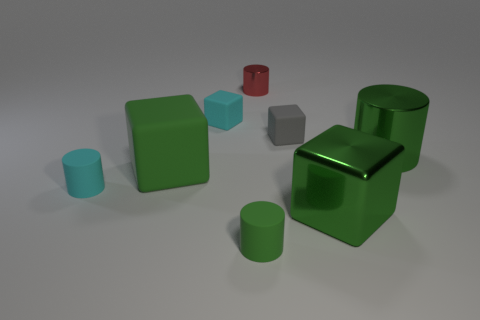Do the gray object and the tiny red thing have the same shape?
Keep it short and to the point. No. There is a gray block that is in front of the tiny matte cube that is left of the small thing that is right of the tiny metal object; what is its size?
Your response must be concise. Small. What number of other things are there of the same material as the small red object
Offer a very short reply. 2. There is a metallic object that is behind the small gray thing; what is its color?
Make the answer very short. Red. There is a green cylinder to the right of the tiny rubber thing that is in front of the block to the right of the small gray rubber object; what is its material?
Provide a succinct answer. Metal. Is there another red metallic thing of the same shape as the small red metallic thing?
Offer a very short reply. No. The red metallic object that is the same size as the gray block is what shape?
Ensure brevity in your answer.  Cylinder. How many cylinders are on the left side of the big green shiny block and behind the big green matte block?
Provide a succinct answer. 1. Is the number of small gray blocks that are on the left side of the tiny green matte thing less than the number of big blue cubes?
Your response must be concise. No. Is there a cyan cube that has the same size as the gray thing?
Offer a terse response. Yes. 